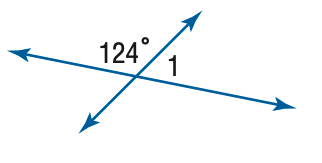Question: Find the measure of \angle 1.
Choices:
A. 56
B. 66
C. 76
D. 86
Answer with the letter. Answer: A 